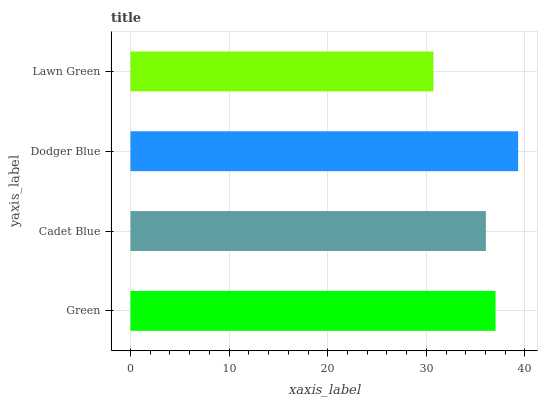Is Lawn Green the minimum?
Answer yes or no. Yes. Is Dodger Blue the maximum?
Answer yes or no. Yes. Is Cadet Blue the minimum?
Answer yes or no. No. Is Cadet Blue the maximum?
Answer yes or no. No. Is Green greater than Cadet Blue?
Answer yes or no. Yes. Is Cadet Blue less than Green?
Answer yes or no. Yes. Is Cadet Blue greater than Green?
Answer yes or no. No. Is Green less than Cadet Blue?
Answer yes or no. No. Is Green the high median?
Answer yes or no. Yes. Is Cadet Blue the low median?
Answer yes or no. Yes. Is Lawn Green the high median?
Answer yes or no. No. Is Green the low median?
Answer yes or no. No. 